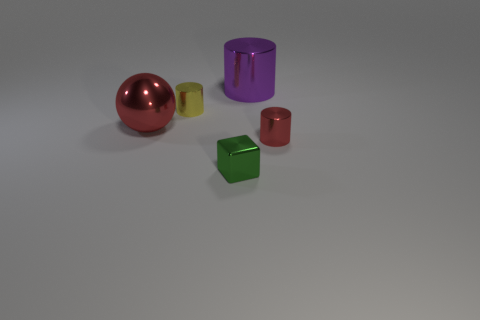Subtract all yellow cylinders. How many cylinders are left? 2 Add 4 metallic blocks. How many objects exist? 9 Subtract all purple cylinders. How many cylinders are left? 2 Subtract all balls. How many objects are left? 4 Subtract 1 cylinders. How many cylinders are left? 2 Add 2 purple cylinders. How many purple cylinders are left? 3 Add 3 gray cubes. How many gray cubes exist? 3 Subtract 0 red cubes. How many objects are left? 5 Subtract all cyan spheres. Subtract all green cylinders. How many spheres are left? 1 Subtract all purple shiny spheres. Subtract all cubes. How many objects are left? 4 